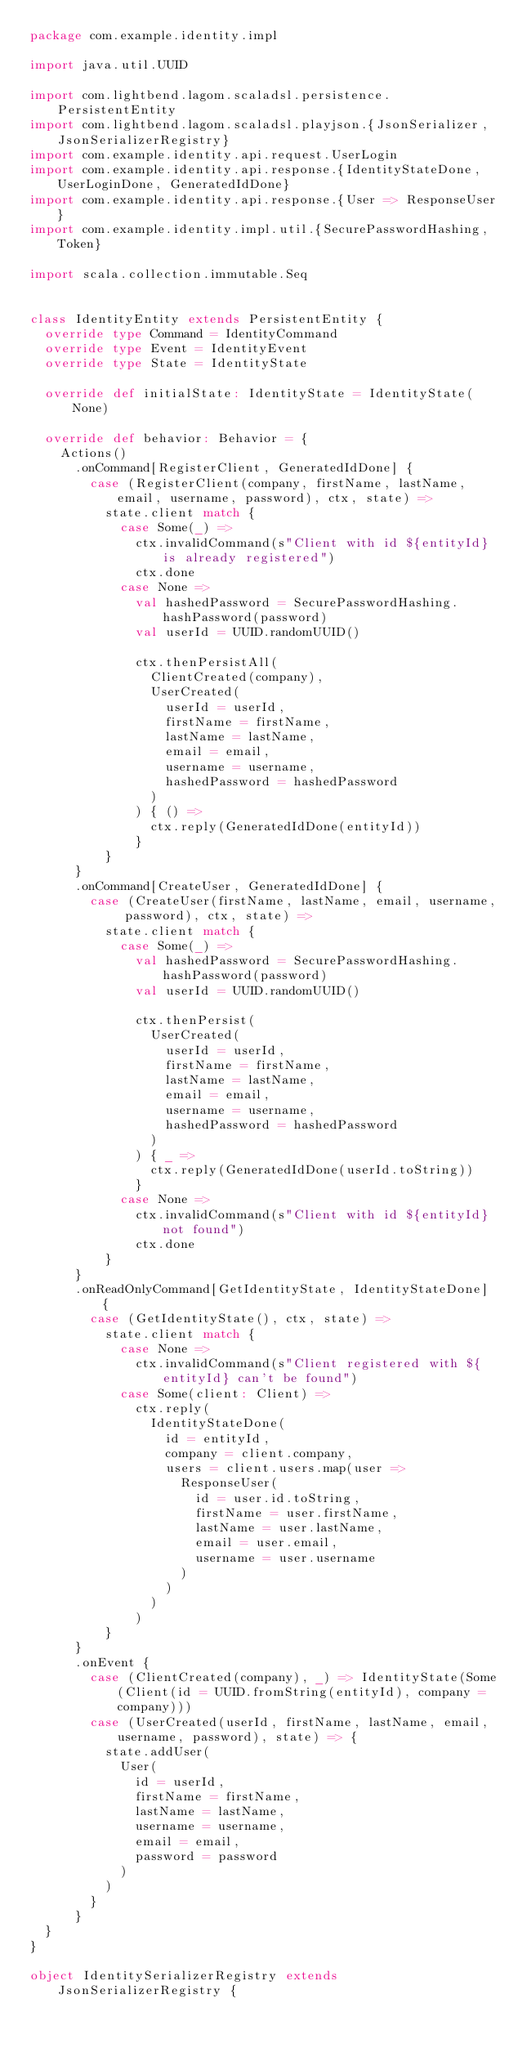<code> <loc_0><loc_0><loc_500><loc_500><_Scala_>package com.example.identity.impl

import java.util.UUID

import com.lightbend.lagom.scaladsl.persistence.PersistentEntity
import com.lightbend.lagom.scaladsl.playjson.{JsonSerializer, JsonSerializerRegistry}
import com.example.identity.api.request.UserLogin
import com.example.identity.api.response.{IdentityStateDone, UserLoginDone, GeneratedIdDone}
import com.example.identity.api.response.{User => ResponseUser}
import com.example.identity.impl.util.{SecurePasswordHashing, Token}

import scala.collection.immutable.Seq


class IdentityEntity extends PersistentEntity {
  override type Command = IdentityCommand
  override type Event = IdentityEvent
  override type State = IdentityState

  override def initialState: IdentityState = IdentityState(None)

  override def behavior: Behavior = {
    Actions()
      .onCommand[RegisterClient, GeneratedIdDone] {
        case (RegisterClient(company, firstName, lastName, email, username, password), ctx, state) =>
          state.client match {
            case Some(_) =>
              ctx.invalidCommand(s"Client with id ${entityId} is already registered")
              ctx.done
            case None =>
              val hashedPassword = SecurePasswordHashing.hashPassword(password)
              val userId = UUID.randomUUID()

              ctx.thenPersistAll(
                ClientCreated(company),
                UserCreated(
                  userId = userId,
                  firstName = firstName,
                  lastName = lastName,
                  email = email,
                  username = username,
                  hashedPassword = hashedPassword
                )
              ) { () =>
                ctx.reply(GeneratedIdDone(entityId))
              }
          }
      }
      .onCommand[CreateUser, GeneratedIdDone] {
        case (CreateUser(firstName, lastName, email, username, password), ctx, state) =>
          state.client match {
            case Some(_) =>
              val hashedPassword = SecurePasswordHashing.hashPassword(password)
              val userId = UUID.randomUUID()

              ctx.thenPersist(
                UserCreated(
                  userId = userId,
                  firstName = firstName,
                  lastName = lastName,
                  email = email,
                  username = username,
                  hashedPassword = hashedPassword
                )
              ) { _ =>
                ctx.reply(GeneratedIdDone(userId.toString))
              }
            case None =>
              ctx.invalidCommand(s"Client with id ${entityId} not found")
              ctx.done
          }
      }
      .onReadOnlyCommand[GetIdentityState, IdentityStateDone] {
        case (GetIdentityState(), ctx, state) =>
          state.client match {
            case None =>
              ctx.invalidCommand(s"Client registered with ${entityId} can't be found")
            case Some(client: Client) =>
              ctx.reply(
                IdentityStateDone(
                  id = entityId,
                  company = client.company,
                  users = client.users.map(user =>
                    ResponseUser(
                      id = user.id.toString,
                      firstName = user.firstName,
                      lastName = user.lastName,
                      email = user.email,
                      username = user.username
                    )
                  )
                )
              )
          }
      }
      .onEvent {
        case (ClientCreated(company), _) => IdentityState(Some(Client(id = UUID.fromString(entityId), company = company)))
        case (UserCreated(userId, firstName, lastName, email, username, password), state) => {
          state.addUser(
            User(
              id = userId,
              firstName = firstName,
              lastName = lastName,
              username = username,
              email = email,
              password = password
            )
          )
        }
      }
  }
}

object IdentitySerializerRegistry extends JsonSerializerRegistry {</code> 